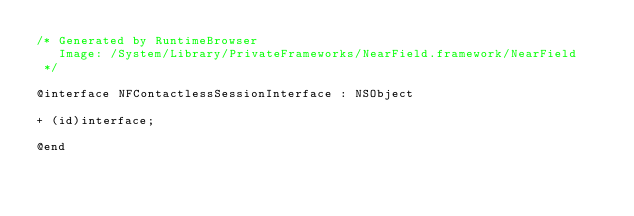Convert code to text. <code><loc_0><loc_0><loc_500><loc_500><_C_>/* Generated by RuntimeBrowser
   Image: /System/Library/PrivateFrameworks/NearField.framework/NearField
 */

@interface NFContactlessSessionInterface : NSObject

+ (id)interface;

@end
</code> 